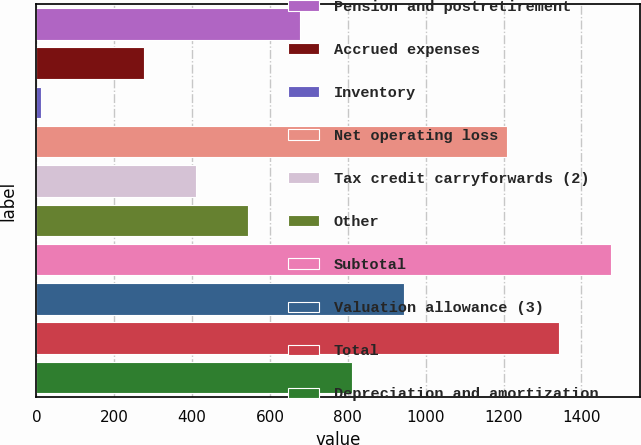Convert chart. <chart><loc_0><loc_0><loc_500><loc_500><bar_chart><fcel>Pension and postretirement<fcel>Accrued expenses<fcel>Inventory<fcel>Net operating loss<fcel>Tax credit carryforwards (2)<fcel>Other<fcel>Subtotal<fcel>Valuation allowance (3)<fcel>Total<fcel>Depreciation and amortization<nl><fcel>677<fcel>277.4<fcel>11<fcel>1209.8<fcel>410.6<fcel>543.8<fcel>1476.2<fcel>943.4<fcel>1343<fcel>810.2<nl></chart> 